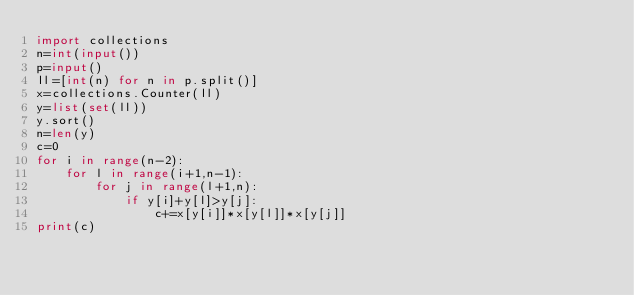Convert code to text. <code><loc_0><loc_0><loc_500><loc_500><_Python_>import collections
n=int(input())
p=input()
ll=[int(n) for n in p.split()]
x=collections.Counter(ll)
y=list(set(ll))
y.sort()
n=len(y)
c=0
for i in range(n-2):
    for l in range(i+1,n-1):
        for j in range(l+1,n):
            if y[i]+y[l]>y[j]:
                c+=x[y[i]]*x[y[l]]*x[y[j]]
print(c)</code> 